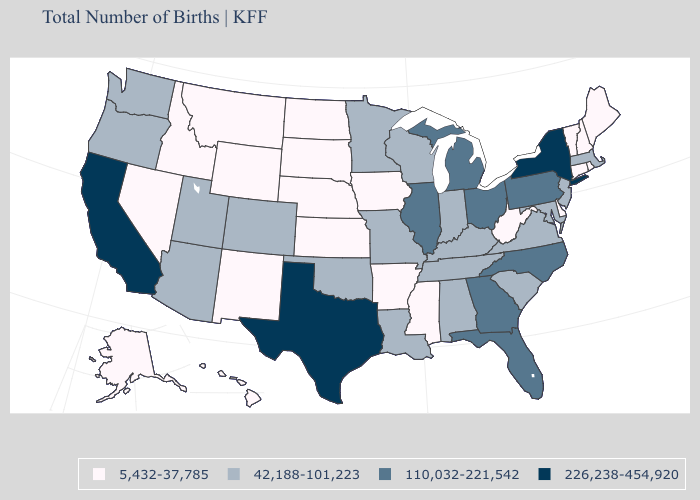Name the states that have a value in the range 5,432-37,785?
Give a very brief answer. Alaska, Arkansas, Connecticut, Delaware, Hawaii, Idaho, Iowa, Kansas, Maine, Mississippi, Montana, Nebraska, Nevada, New Hampshire, New Mexico, North Dakota, Rhode Island, South Dakota, Vermont, West Virginia, Wyoming. What is the value of Illinois?
Answer briefly. 110,032-221,542. What is the value of Pennsylvania?
Write a very short answer. 110,032-221,542. Which states have the lowest value in the South?
Quick response, please. Arkansas, Delaware, Mississippi, West Virginia. What is the value of Hawaii?
Give a very brief answer. 5,432-37,785. What is the value of Virginia?
Answer briefly. 42,188-101,223. Name the states that have a value in the range 110,032-221,542?
Answer briefly. Florida, Georgia, Illinois, Michigan, North Carolina, Ohio, Pennsylvania. Name the states that have a value in the range 42,188-101,223?
Answer briefly. Alabama, Arizona, Colorado, Indiana, Kentucky, Louisiana, Maryland, Massachusetts, Minnesota, Missouri, New Jersey, Oklahoma, Oregon, South Carolina, Tennessee, Utah, Virginia, Washington, Wisconsin. Does the map have missing data?
Give a very brief answer. No. Does the first symbol in the legend represent the smallest category?
Concise answer only. Yes. Among the states that border New Hampshire , which have the highest value?
Keep it brief. Massachusetts. How many symbols are there in the legend?
Quick response, please. 4. What is the highest value in the USA?
Concise answer only. 226,238-454,920. Among the states that border Wyoming , does Montana have the highest value?
Keep it brief. No. Name the states that have a value in the range 42,188-101,223?
Short answer required. Alabama, Arizona, Colorado, Indiana, Kentucky, Louisiana, Maryland, Massachusetts, Minnesota, Missouri, New Jersey, Oklahoma, Oregon, South Carolina, Tennessee, Utah, Virginia, Washington, Wisconsin. 